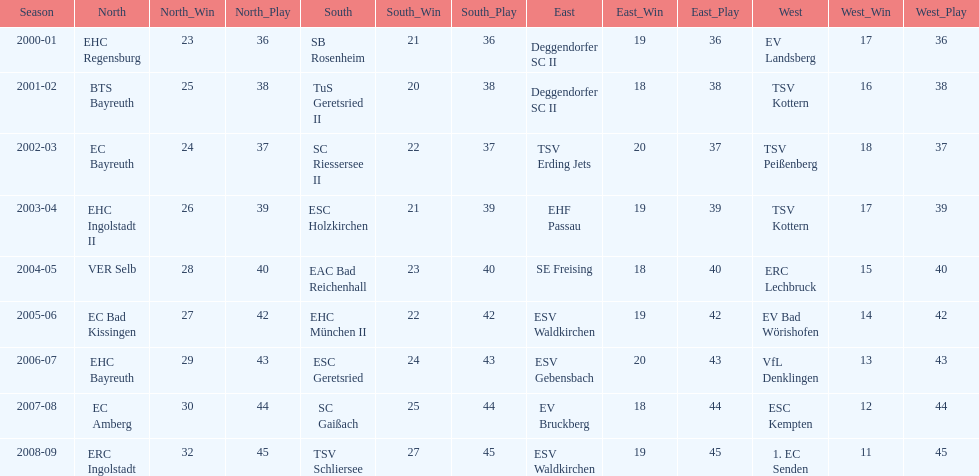What was the first club for the north in the 2000's? EHC Regensburg. 